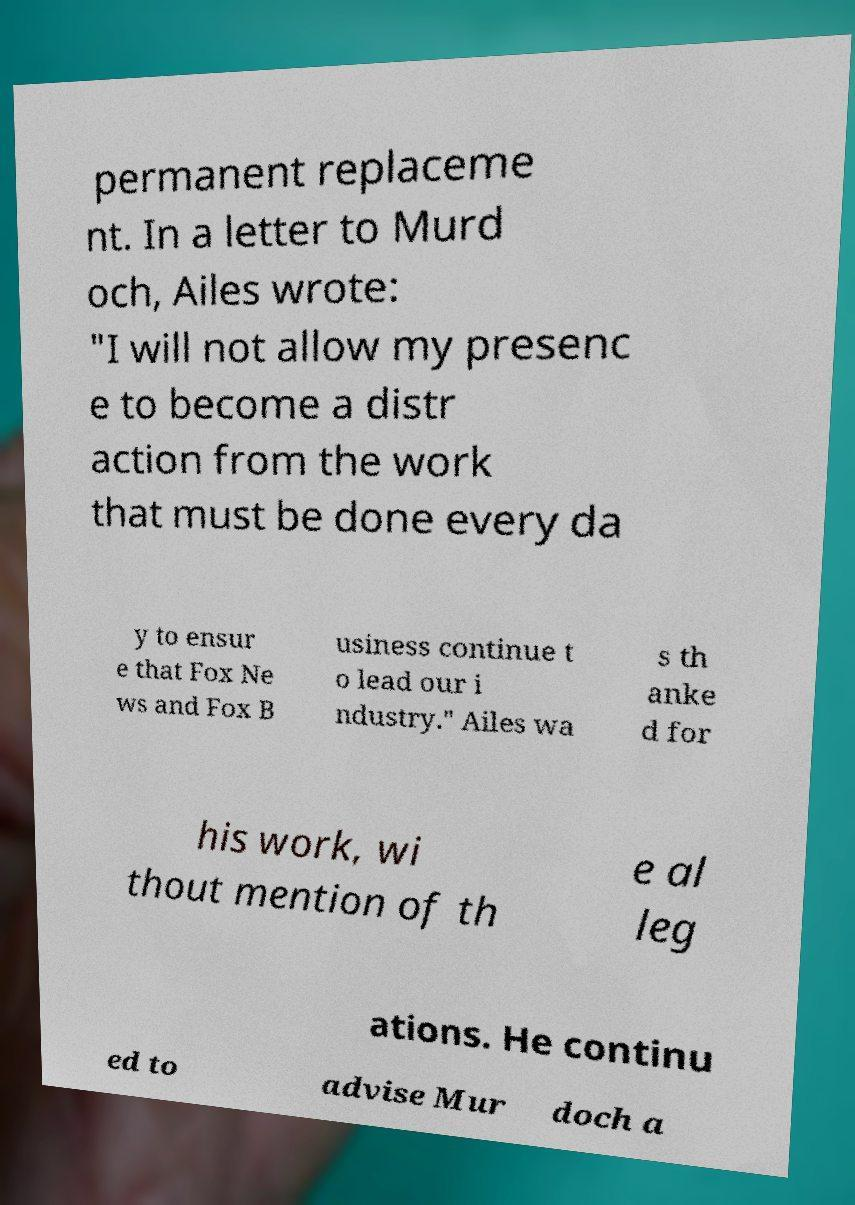For documentation purposes, I need the text within this image transcribed. Could you provide that? permanent replaceme nt. In a letter to Murd och, Ailes wrote: "I will not allow my presenc e to become a distr action from the work that must be done every da y to ensur e that Fox Ne ws and Fox B usiness continue t o lead our i ndustry." Ailes wa s th anke d for his work, wi thout mention of th e al leg ations. He continu ed to advise Mur doch a 